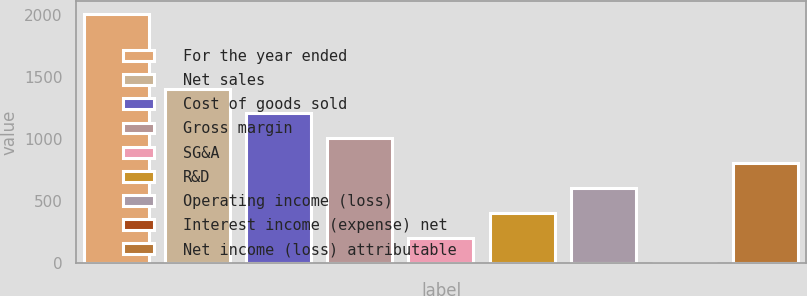Convert chart. <chart><loc_0><loc_0><loc_500><loc_500><bar_chart><fcel>For the year ended<fcel>Net sales<fcel>Cost of goods sold<fcel>Gross margin<fcel>SG&A<fcel>R&D<fcel>Operating income (loss)<fcel>Interest income (expense) net<fcel>Net income (loss) attributable<nl><fcel>2010<fcel>1407.6<fcel>1206.8<fcel>1006<fcel>202.8<fcel>403.6<fcel>604.4<fcel>2<fcel>805.2<nl></chart> 